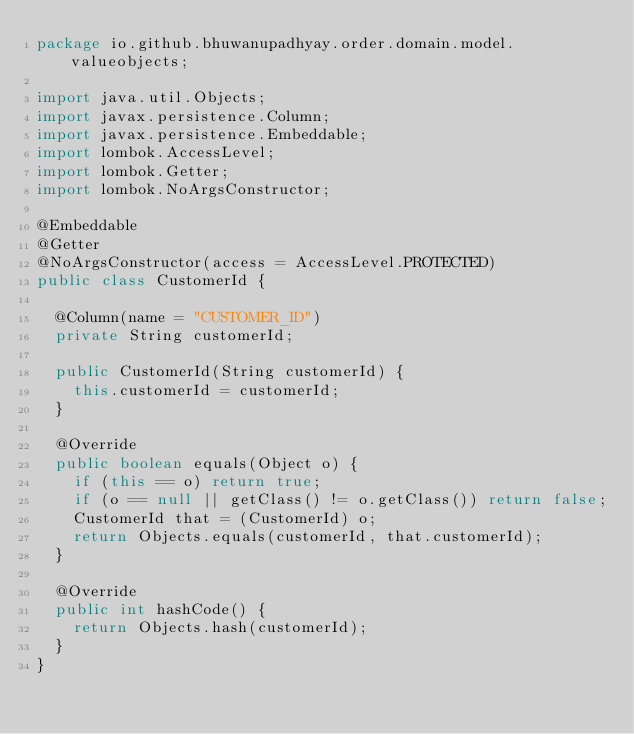Convert code to text. <code><loc_0><loc_0><loc_500><loc_500><_Java_>package io.github.bhuwanupadhyay.order.domain.model.valueobjects;

import java.util.Objects;
import javax.persistence.Column;
import javax.persistence.Embeddable;
import lombok.AccessLevel;
import lombok.Getter;
import lombok.NoArgsConstructor;

@Embeddable
@Getter
@NoArgsConstructor(access = AccessLevel.PROTECTED)
public class CustomerId {

  @Column(name = "CUSTOMER_ID")
  private String customerId;

  public CustomerId(String customerId) {
    this.customerId = customerId;
  }

  @Override
  public boolean equals(Object o) {
    if (this == o) return true;
    if (o == null || getClass() != o.getClass()) return false;
    CustomerId that = (CustomerId) o;
    return Objects.equals(customerId, that.customerId);
  }

  @Override
  public int hashCode() {
    return Objects.hash(customerId);
  }
}
</code> 